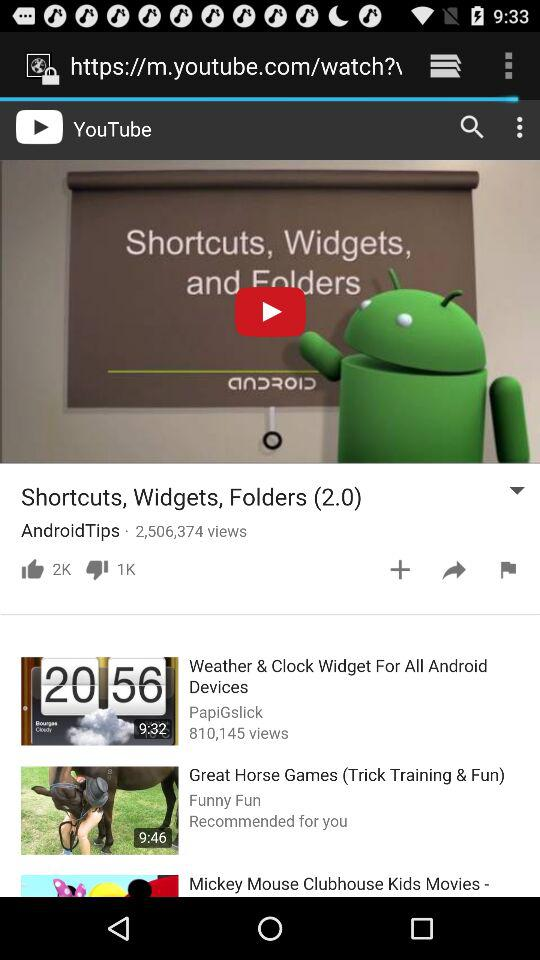What is the duration of the recommended video? The duration is 9:46. 